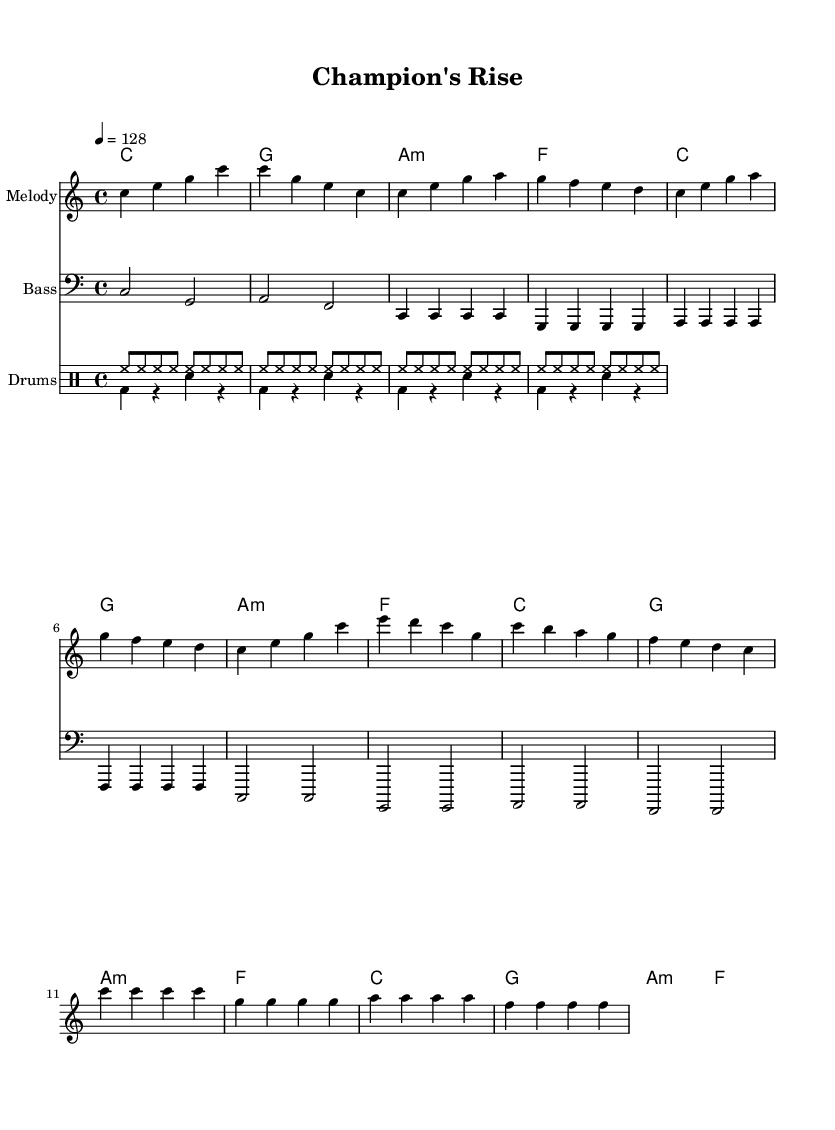What is the key signature of this music? The key signature is C major, which is indicated at the beginning of the score. There are no sharps or flats, hence it is in the key of C.
Answer: C major What is the time signature of the piece? The time signature is located at the beginning of the score, and it reads 4/4, indicating that there are four beats in each measure and the quarter note receives one beat.
Answer: 4/4 What is the tempo marking given in the score? The tempo marking can be found at the start of the score, indicating that the piece should be played at a speed of quarter note equals 128 beats per minute.
Answer: 128 How many measures are in the melody section? By counting the measures in the melody section as indicated in the notation, there are a total of 12 measures present in the melody part.
Answer: 12 What is the main instrument used for the melody in this piece? The main instrument for the melody is indicated in the staff section, which is labeled as "Melody." Usually, in electronic pieces, this could be a synthesizer or similar electronic instrument.
Answer: Melody In which section does the "Drop" occur? The "Drop" occurs as marked in the melody section where the notes change to emphasize a rhythmic and dynamic shift, occurring after the "Build-up" section.
Answer: Drop What type of rhythm pattern is used in the drums' up section? The rhythm pattern is specified in the drum part, where it consists of eight hi-hat notes played in succession, indicating a steady and consistent rhythm to drive the energetic feel of the anthem.
Answer: Hi-hat 